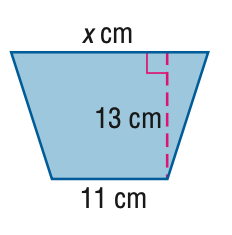Question: Find x. A = 177 cm^2.
Choices:
A. 13.6
B. 14.8
C. 16.1
D. 16.2
Answer with the letter. Answer: D 